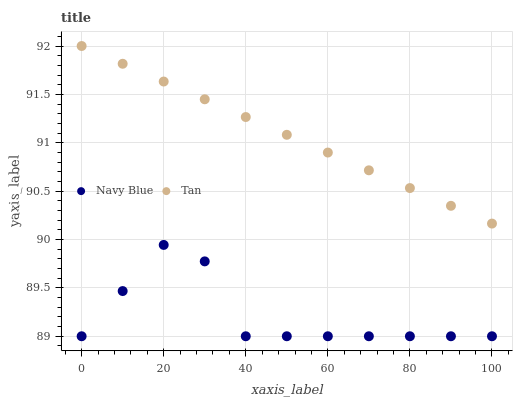Does Navy Blue have the minimum area under the curve?
Answer yes or no. Yes. Does Tan have the maximum area under the curve?
Answer yes or no. Yes. Does Tan have the minimum area under the curve?
Answer yes or no. No. Is Tan the smoothest?
Answer yes or no. Yes. Is Navy Blue the roughest?
Answer yes or no. Yes. Is Tan the roughest?
Answer yes or no. No. Does Navy Blue have the lowest value?
Answer yes or no. Yes. Does Tan have the lowest value?
Answer yes or no. No. Does Tan have the highest value?
Answer yes or no. Yes. Is Navy Blue less than Tan?
Answer yes or no. Yes. Is Tan greater than Navy Blue?
Answer yes or no. Yes. Does Navy Blue intersect Tan?
Answer yes or no. No. 